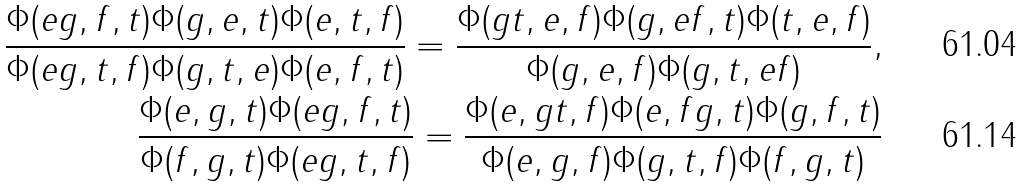<formula> <loc_0><loc_0><loc_500><loc_500>\frac { \Phi ( e g , f , t ) \Phi ( g , e , t ) \Phi ( e , t , f ) } { \Phi ( e g , t , f ) \Phi ( g , t , e ) \Phi ( e , f , t ) } = \frac { \Phi ( g t , e , f ) \Phi ( g , e f , t ) \Phi ( t , e , f ) } { \Phi ( g , e , f ) \Phi ( g , t , e f ) } , \\ \frac { \Phi ( e , g , t ) \Phi ( e g , f , t ) } { \Phi ( f , g , t ) \Phi ( e g , t , f ) } = \frac { \Phi ( e , g t , f ) \Phi ( e , f g , t ) \Phi ( g , f , t ) } { \Phi ( e , g , f ) \Phi ( g , t , f ) \Phi ( f , g , t ) }</formula> 